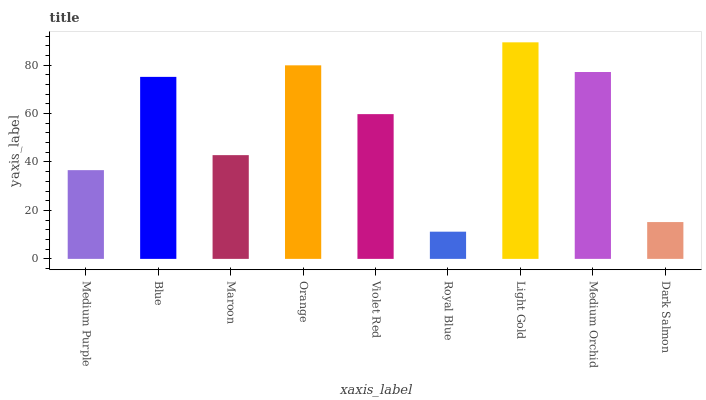Is Blue the minimum?
Answer yes or no. No. Is Blue the maximum?
Answer yes or no. No. Is Blue greater than Medium Purple?
Answer yes or no. Yes. Is Medium Purple less than Blue?
Answer yes or no. Yes. Is Medium Purple greater than Blue?
Answer yes or no. No. Is Blue less than Medium Purple?
Answer yes or no. No. Is Violet Red the high median?
Answer yes or no. Yes. Is Violet Red the low median?
Answer yes or no. Yes. Is Medium Orchid the high median?
Answer yes or no. No. Is Blue the low median?
Answer yes or no. No. 